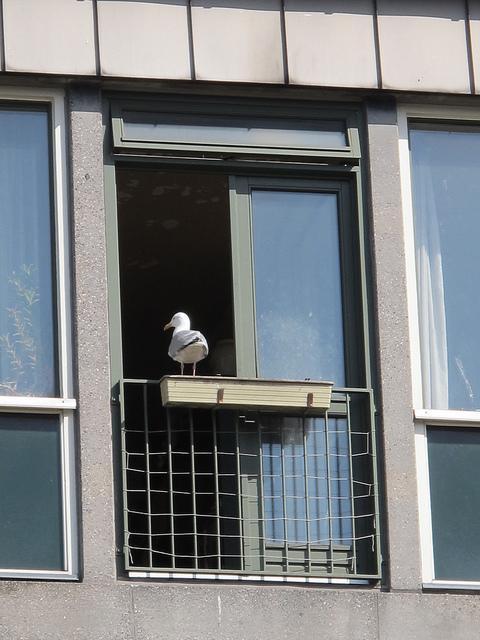How many birds are on the left windowsill?
Give a very brief answer. 1. How many people are wearing glasses?
Give a very brief answer. 0. 